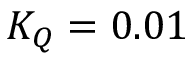<formula> <loc_0><loc_0><loc_500><loc_500>K _ { Q } = 0 . 0 1</formula> 